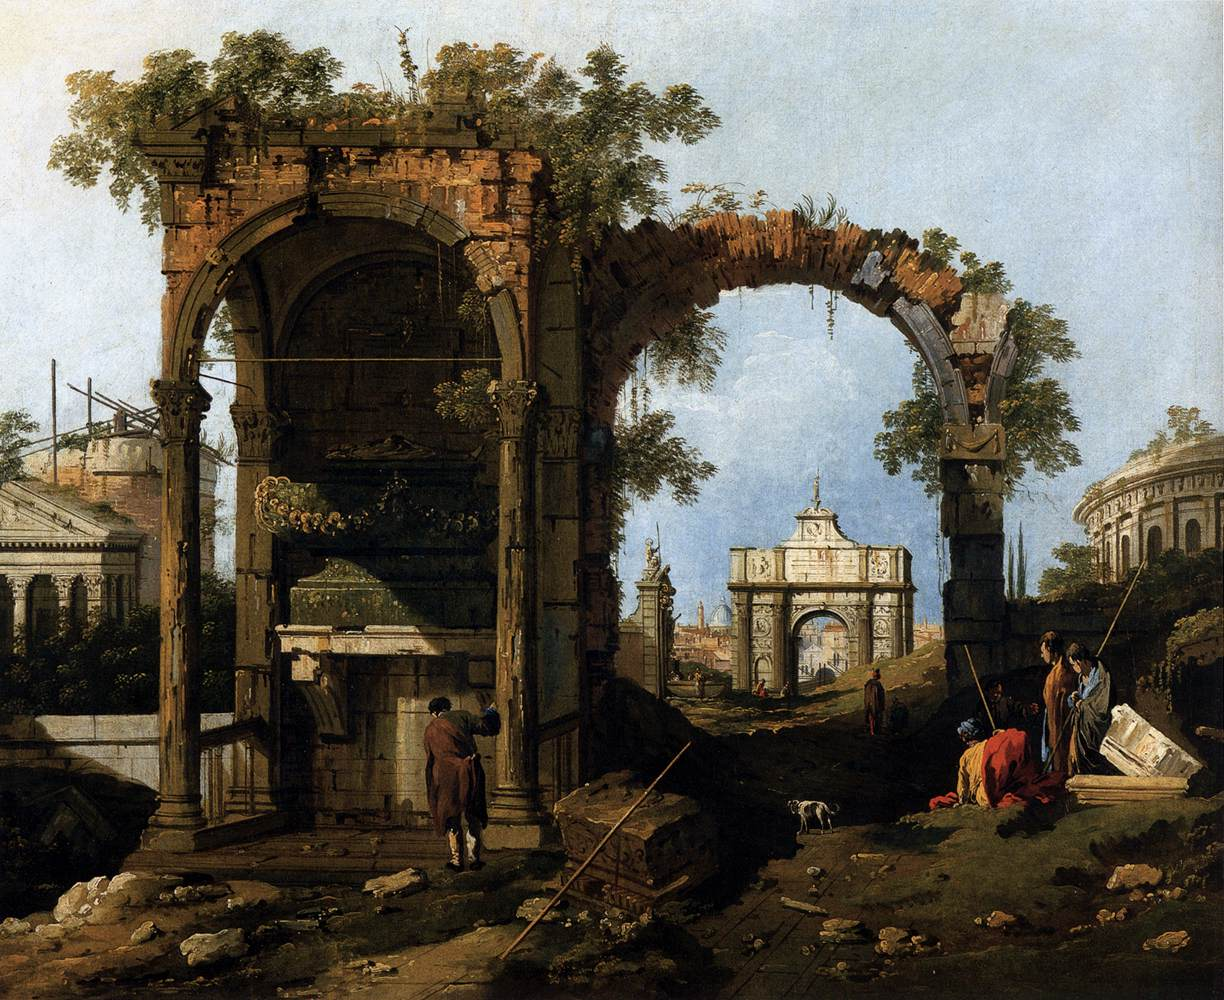Which stories do you think the people in the painting might be telling? Be very creative! In the painting, the figures might be sharing tales of legendary heroes and ancient civilizations that once thrived where the ruins now stand. One figure could be a bard, narrating the saga of a powerful emperor who built the grand archway centuries ago, detailing his glorious conquests and eventual fall. Another might be recounting a fable about the mysterious creature said to live in the ruins, drawing the children into a world of mythology and wonder. The group might also be discussing the plans for a grand festival to honor the spirits of their ancestors, weaving stories of their rich cultural heritage and dreams for the future. Each conversation is steeped in the lore and mysteries of the past, bringing the scene to life with imaginative narratives. 